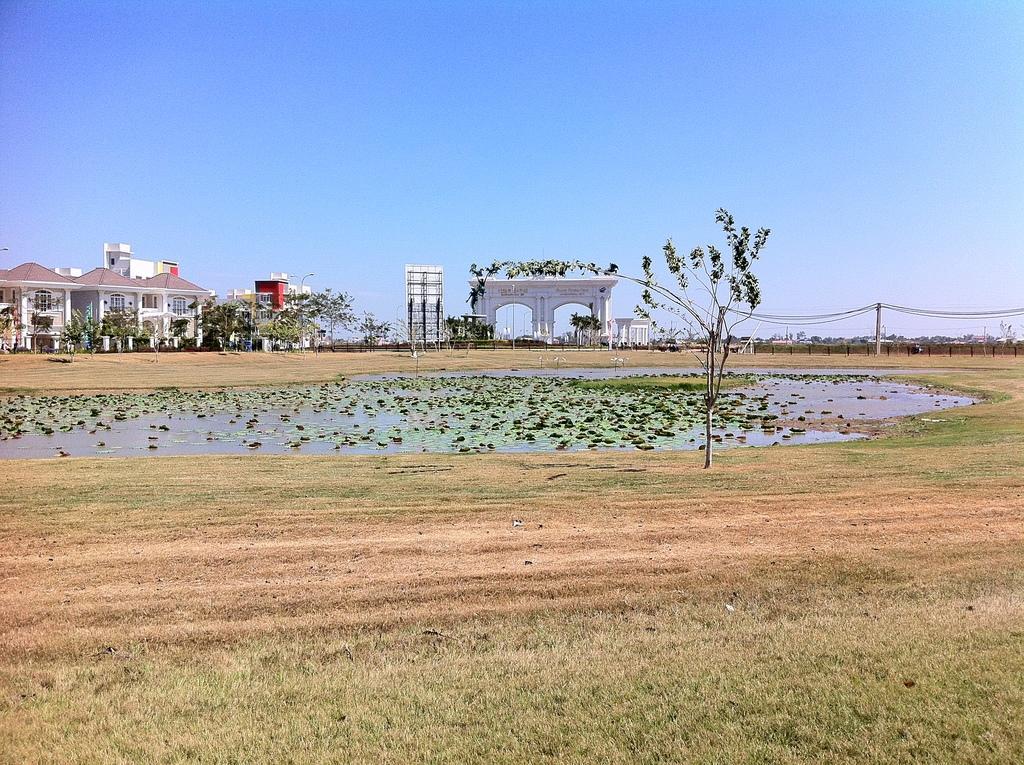Could you give a brief overview of what you see in this image? In this picture we can see water, trees, grass, buildings with windows, hoarding, fence and in the background we can see sky. 